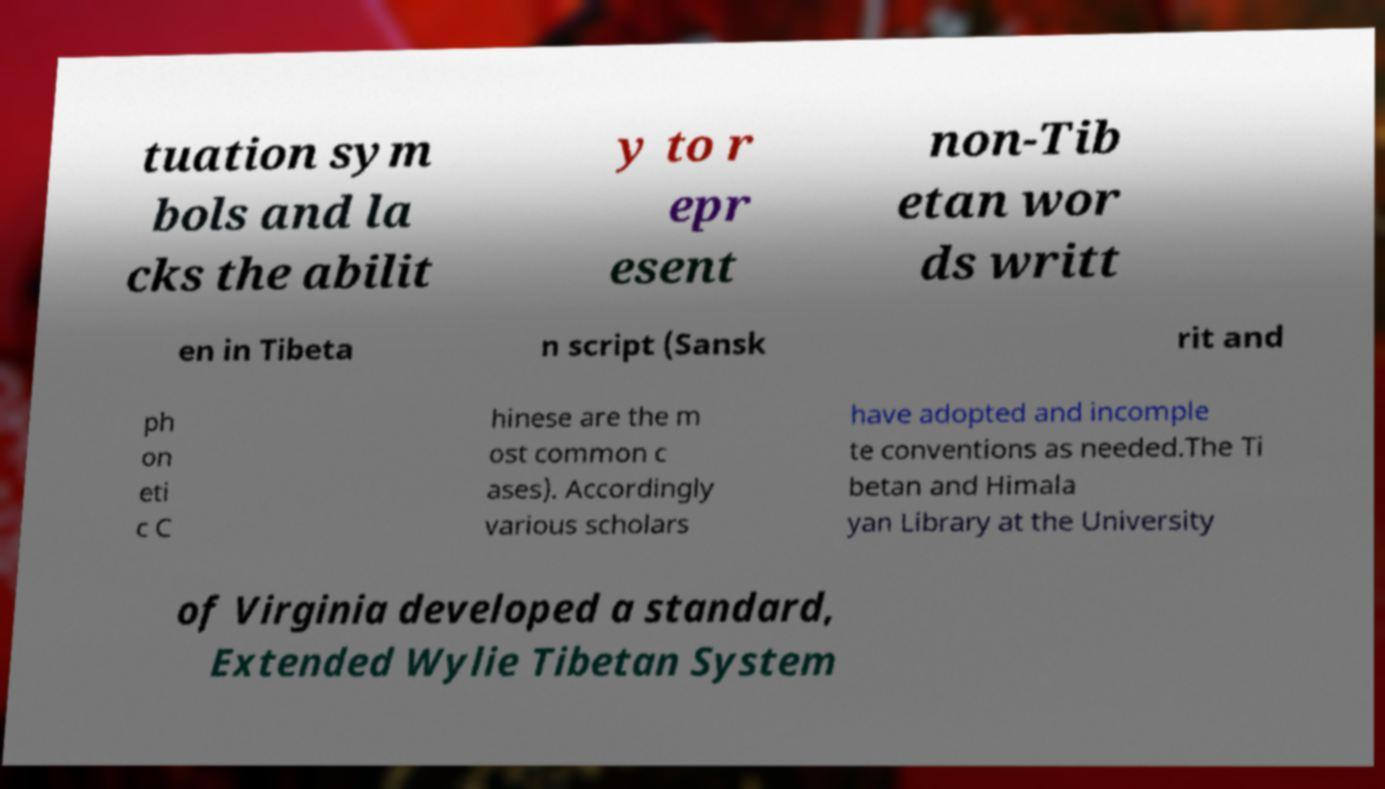For documentation purposes, I need the text within this image transcribed. Could you provide that? tuation sym bols and la cks the abilit y to r epr esent non-Tib etan wor ds writt en in Tibeta n script (Sansk rit and ph on eti c C hinese are the m ost common c ases). Accordingly various scholars have adopted and incomple te conventions as needed.The Ti betan and Himala yan Library at the University of Virginia developed a standard, Extended Wylie Tibetan System 